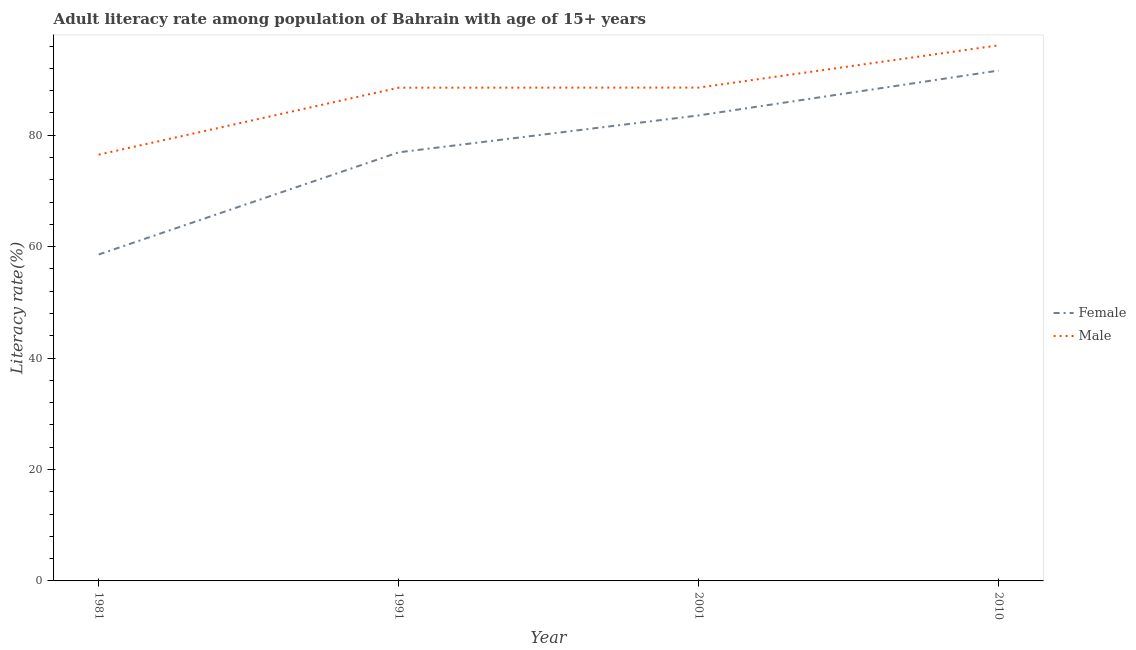How many different coloured lines are there?
Offer a terse response. 2. Does the line corresponding to female adult literacy rate intersect with the line corresponding to male adult literacy rate?
Ensure brevity in your answer.  No. What is the female adult literacy rate in 2001?
Ensure brevity in your answer.  83.56. Across all years, what is the maximum male adult literacy rate?
Offer a terse response. 96.14. Across all years, what is the minimum female adult literacy rate?
Ensure brevity in your answer.  58.59. In which year was the male adult literacy rate maximum?
Make the answer very short. 2010. In which year was the female adult literacy rate minimum?
Ensure brevity in your answer.  1981. What is the total male adult literacy rate in the graph?
Offer a very short reply. 349.75. What is the difference between the male adult literacy rate in 1981 and that in 2001?
Keep it short and to the point. -12.04. What is the difference between the female adult literacy rate in 2001 and the male adult literacy rate in 2010?
Your answer should be very brief. -12.58. What is the average female adult literacy rate per year?
Ensure brevity in your answer.  77.67. In the year 2001, what is the difference between the male adult literacy rate and female adult literacy rate?
Ensure brevity in your answer.  5. What is the ratio of the male adult literacy rate in 1991 to that in 2001?
Provide a short and direct response. 1. Is the female adult literacy rate in 2001 less than that in 2010?
Your response must be concise. Yes. Is the difference between the male adult literacy rate in 1981 and 2001 greater than the difference between the female adult literacy rate in 1981 and 2001?
Provide a succinct answer. Yes. What is the difference between the highest and the second highest male adult literacy rate?
Ensure brevity in your answer.  7.59. What is the difference between the highest and the lowest male adult literacy rate?
Offer a terse response. 19.62. In how many years, is the female adult literacy rate greater than the average female adult literacy rate taken over all years?
Ensure brevity in your answer.  2. Is the female adult literacy rate strictly less than the male adult literacy rate over the years?
Make the answer very short. Yes. How many years are there in the graph?
Provide a succinct answer. 4. What is the difference between two consecutive major ticks on the Y-axis?
Your answer should be compact. 20. Does the graph contain any zero values?
Keep it short and to the point. No. Where does the legend appear in the graph?
Your answer should be compact. Center right. How many legend labels are there?
Keep it short and to the point. 2. How are the legend labels stacked?
Keep it short and to the point. Vertical. What is the title of the graph?
Offer a terse response. Adult literacy rate among population of Bahrain with age of 15+ years. What is the label or title of the X-axis?
Provide a succinct answer. Year. What is the label or title of the Y-axis?
Offer a very short reply. Literacy rate(%). What is the Literacy rate(%) of Female in 1981?
Provide a short and direct response. 58.59. What is the Literacy rate(%) in Male in 1981?
Ensure brevity in your answer.  76.52. What is the Literacy rate(%) in Female in 1991?
Your response must be concise. 76.93. What is the Literacy rate(%) in Male in 1991?
Your response must be concise. 88.54. What is the Literacy rate(%) in Female in 2001?
Your response must be concise. 83.56. What is the Literacy rate(%) in Male in 2001?
Make the answer very short. 88.55. What is the Literacy rate(%) of Female in 2010?
Your response must be concise. 91.61. What is the Literacy rate(%) of Male in 2010?
Your response must be concise. 96.14. Across all years, what is the maximum Literacy rate(%) of Female?
Your answer should be very brief. 91.61. Across all years, what is the maximum Literacy rate(%) of Male?
Provide a succinct answer. 96.14. Across all years, what is the minimum Literacy rate(%) in Female?
Your answer should be very brief. 58.59. Across all years, what is the minimum Literacy rate(%) of Male?
Offer a terse response. 76.52. What is the total Literacy rate(%) in Female in the graph?
Make the answer very short. 310.69. What is the total Literacy rate(%) in Male in the graph?
Provide a succinct answer. 349.75. What is the difference between the Literacy rate(%) of Female in 1981 and that in 1991?
Your response must be concise. -18.34. What is the difference between the Literacy rate(%) in Male in 1981 and that in 1991?
Offer a terse response. -12.02. What is the difference between the Literacy rate(%) in Female in 1981 and that in 2001?
Your answer should be compact. -24.97. What is the difference between the Literacy rate(%) of Male in 1981 and that in 2001?
Give a very brief answer. -12.04. What is the difference between the Literacy rate(%) in Female in 1981 and that in 2010?
Give a very brief answer. -33.02. What is the difference between the Literacy rate(%) of Male in 1981 and that in 2010?
Make the answer very short. -19.62. What is the difference between the Literacy rate(%) of Female in 1991 and that in 2001?
Offer a very short reply. -6.63. What is the difference between the Literacy rate(%) in Male in 1991 and that in 2001?
Give a very brief answer. -0.02. What is the difference between the Literacy rate(%) of Female in 1991 and that in 2010?
Offer a terse response. -14.68. What is the difference between the Literacy rate(%) of Male in 1991 and that in 2010?
Your response must be concise. -7.6. What is the difference between the Literacy rate(%) of Female in 2001 and that in 2010?
Your response must be concise. -8.06. What is the difference between the Literacy rate(%) of Male in 2001 and that in 2010?
Provide a succinct answer. -7.59. What is the difference between the Literacy rate(%) of Female in 1981 and the Literacy rate(%) of Male in 1991?
Offer a terse response. -29.95. What is the difference between the Literacy rate(%) in Female in 1981 and the Literacy rate(%) in Male in 2001?
Your answer should be very brief. -29.96. What is the difference between the Literacy rate(%) in Female in 1981 and the Literacy rate(%) in Male in 2010?
Offer a very short reply. -37.55. What is the difference between the Literacy rate(%) in Female in 1991 and the Literacy rate(%) in Male in 2001?
Offer a terse response. -11.62. What is the difference between the Literacy rate(%) in Female in 1991 and the Literacy rate(%) in Male in 2010?
Provide a short and direct response. -19.21. What is the difference between the Literacy rate(%) in Female in 2001 and the Literacy rate(%) in Male in 2010?
Provide a short and direct response. -12.58. What is the average Literacy rate(%) of Female per year?
Make the answer very short. 77.67. What is the average Literacy rate(%) of Male per year?
Keep it short and to the point. 87.44. In the year 1981, what is the difference between the Literacy rate(%) of Female and Literacy rate(%) of Male?
Keep it short and to the point. -17.93. In the year 1991, what is the difference between the Literacy rate(%) in Female and Literacy rate(%) in Male?
Make the answer very short. -11.61. In the year 2001, what is the difference between the Literacy rate(%) of Female and Literacy rate(%) of Male?
Ensure brevity in your answer.  -5. In the year 2010, what is the difference between the Literacy rate(%) in Female and Literacy rate(%) in Male?
Your answer should be compact. -4.53. What is the ratio of the Literacy rate(%) in Female in 1981 to that in 1991?
Your answer should be compact. 0.76. What is the ratio of the Literacy rate(%) of Male in 1981 to that in 1991?
Offer a terse response. 0.86. What is the ratio of the Literacy rate(%) of Female in 1981 to that in 2001?
Ensure brevity in your answer.  0.7. What is the ratio of the Literacy rate(%) of Male in 1981 to that in 2001?
Offer a very short reply. 0.86. What is the ratio of the Literacy rate(%) in Female in 1981 to that in 2010?
Keep it short and to the point. 0.64. What is the ratio of the Literacy rate(%) of Male in 1981 to that in 2010?
Your answer should be very brief. 0.8. What is the ratio of the Literacy rate(%) of Female in 1991 to that in 2001?
Make the answer very short. 0.92. What is the ratio of the Literacy rate(%) in Male in 1991 to that in 2001?
Keep it short and to the point. 1. What is the ratio of the Literacy rate(%) in Female in 1991 to that in 2010?
Provide a short and direct response. 0.84. What is the ratio of the Literacy rate(%) in Male in 1991 to that in 2010?
Provide a short and direct response. 0.92. What is the ratio of the Literacy rate(%) in Female in 2001 to that in 2010?
Give a very brief answer. 0.91. What is the ratio of the Literacy rate(%) in Male in 2001 to that in 2010?
Provide a succinct answer. 0.92. What is the difference between the highest and the second highest Literacy rate(%) of Female?
Ensure brevity in your answer.  8.06. What is the difference between the highest and the second highest Literacy rate(%) in Male?
Offer a terse response. 7.59. What is the difference between the highest and the lowest Literacy rate(%) of Female?
Provide a succinct answer. 33.02. What is the difference between the highest and the lowest Literacy rate(%) in Male?
Your answer should be very brief. 19.62. 